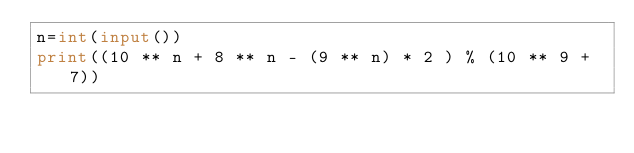Convert code to text. <code><loc_0><loc_0><loc_500><loc_500><_Python_>n=int(input())
print((10 ** n + 8 ** n - (9 ** n) * 2 ) % (10 ** 9 + 7))</code> 